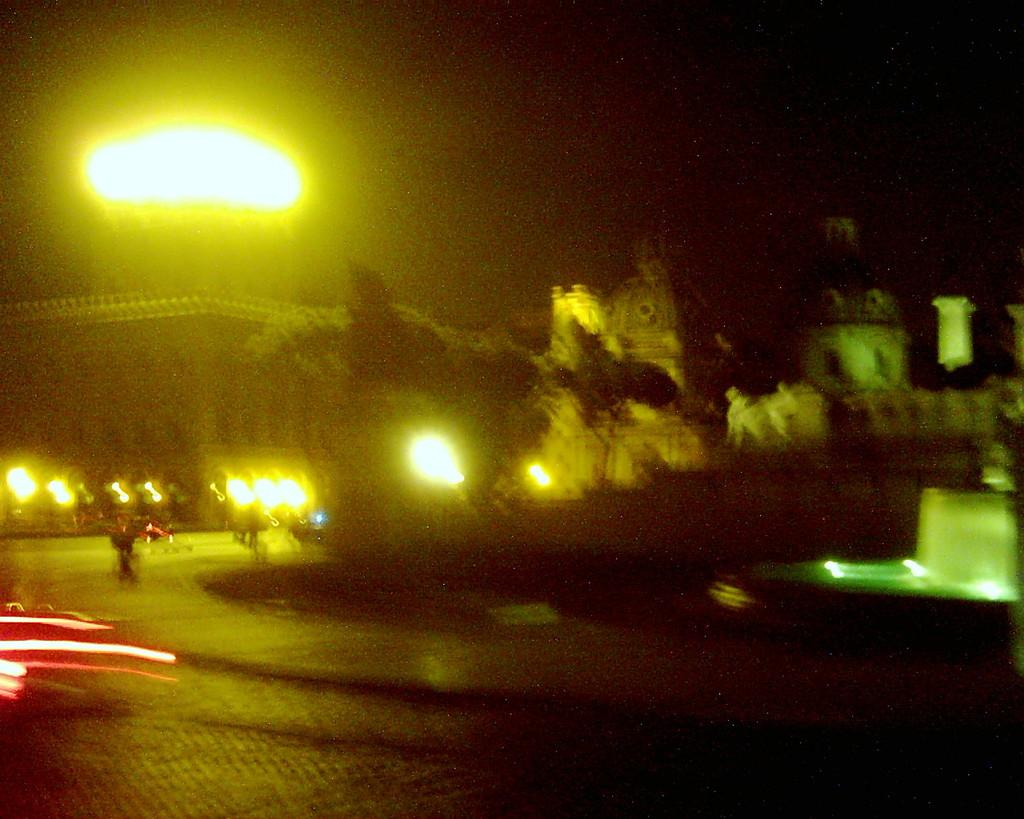What time of day is depicted in the image? The image is a night view. What structures can be seen in the image? There are buildings and a fountain in the image. What type of vegetation is present in the image? There are trees in the image. What lighting is used in the image? There are street lights in the image. What else can be seen on the road in the image? There are vehicles on the road in the image. What type of pen is being used to draw the street in the image? There is no pen or drawing activity present in the image; it is a photograph of a real-life scene. What color is the dress worn by the tree in the image? There are no trees wearing dresses in the image; trees are natural vegetation. 